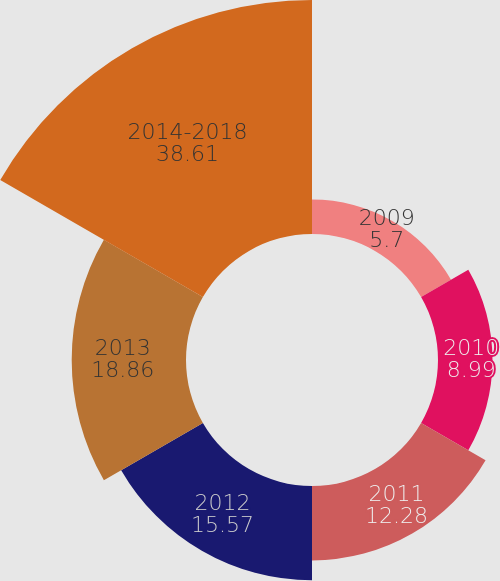<chart> <loc_0><loc_0><loc_500><loc_500><pie_chart><fcel>2009<fcel>2010<fcel>2011<fcel>2012<fcel>2013<fcel>2014-2018<nl><fcel>5.7%<fcel>8.99%<fcel>12.28%<fcel>15.57%<fcel>18.86%<fcel>38.61%<nl></chart> 